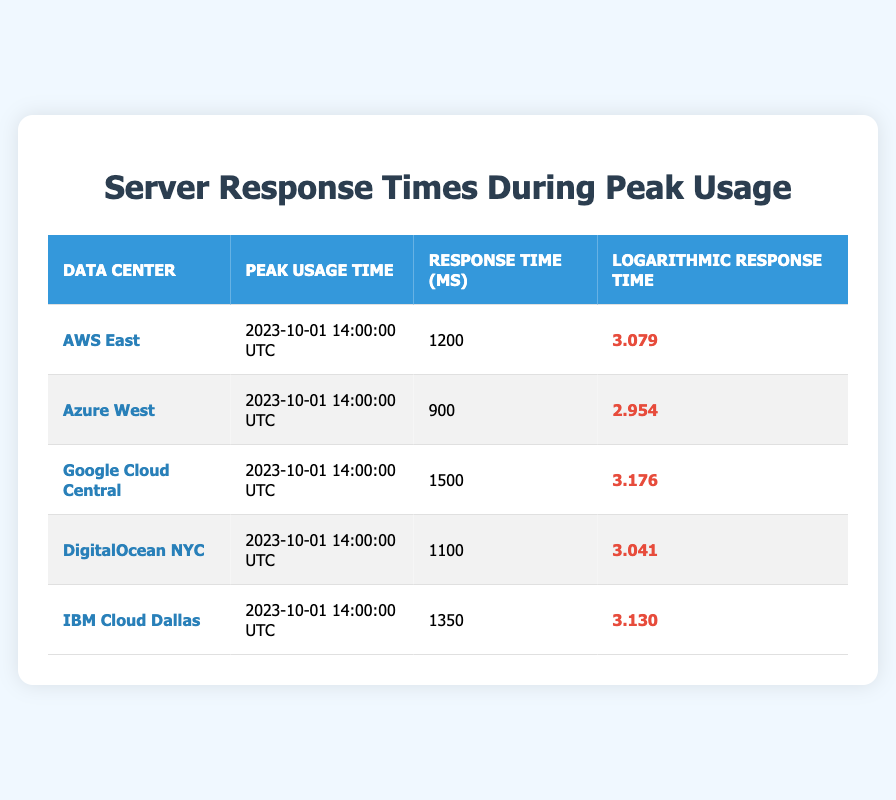What is the response time of Google Cloud Central during peak usage? From the table, locate the row corresponding to Google Cloud Central, which lists its peak usage response time as 1500 ms.
Answer: 1500 ms Which data center had the lowest logarithmic response time? By examining the logarithmic response times in the table, Azure West has the lowest value of 2.954.
Answer: Azure West What is the average response time of all data centers listed? To calculate the average, sum up all the response times: (1200 + 900 + 1500 + 1100 + 1350) = 5050 ms. There are 5 data centers, so the average is 5050/5 = 1010 ms.
Answer: 1010 ms Did all data centers have a response time greater than 800 ms? Check each response time: AWS East (1200 ms), Azure West (900 ms), Google Cloud Central (1500 ms), DigitalOcean NYC (1100 ms), and IBM Cloud Dallas (1350 ms). All values are above 800 ms, indicating that the statement is true.
Answer: Yes What is the difference in logarithmic response time between AWS East and IBM Cloud Dallas? Identify the logarithmic response times: AWS East (3.079) and IBM Cloud Dallas (3.130). The difference is 3.130 - 3.079 = 0.051.
Answer: 0.051 